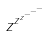Convert formula to latex. <formula><loc_0><loc_0><loc_500><loc_500>z ^ { z ^ { z ^ { - ^ { - ^ { - } } } } }</formula> 